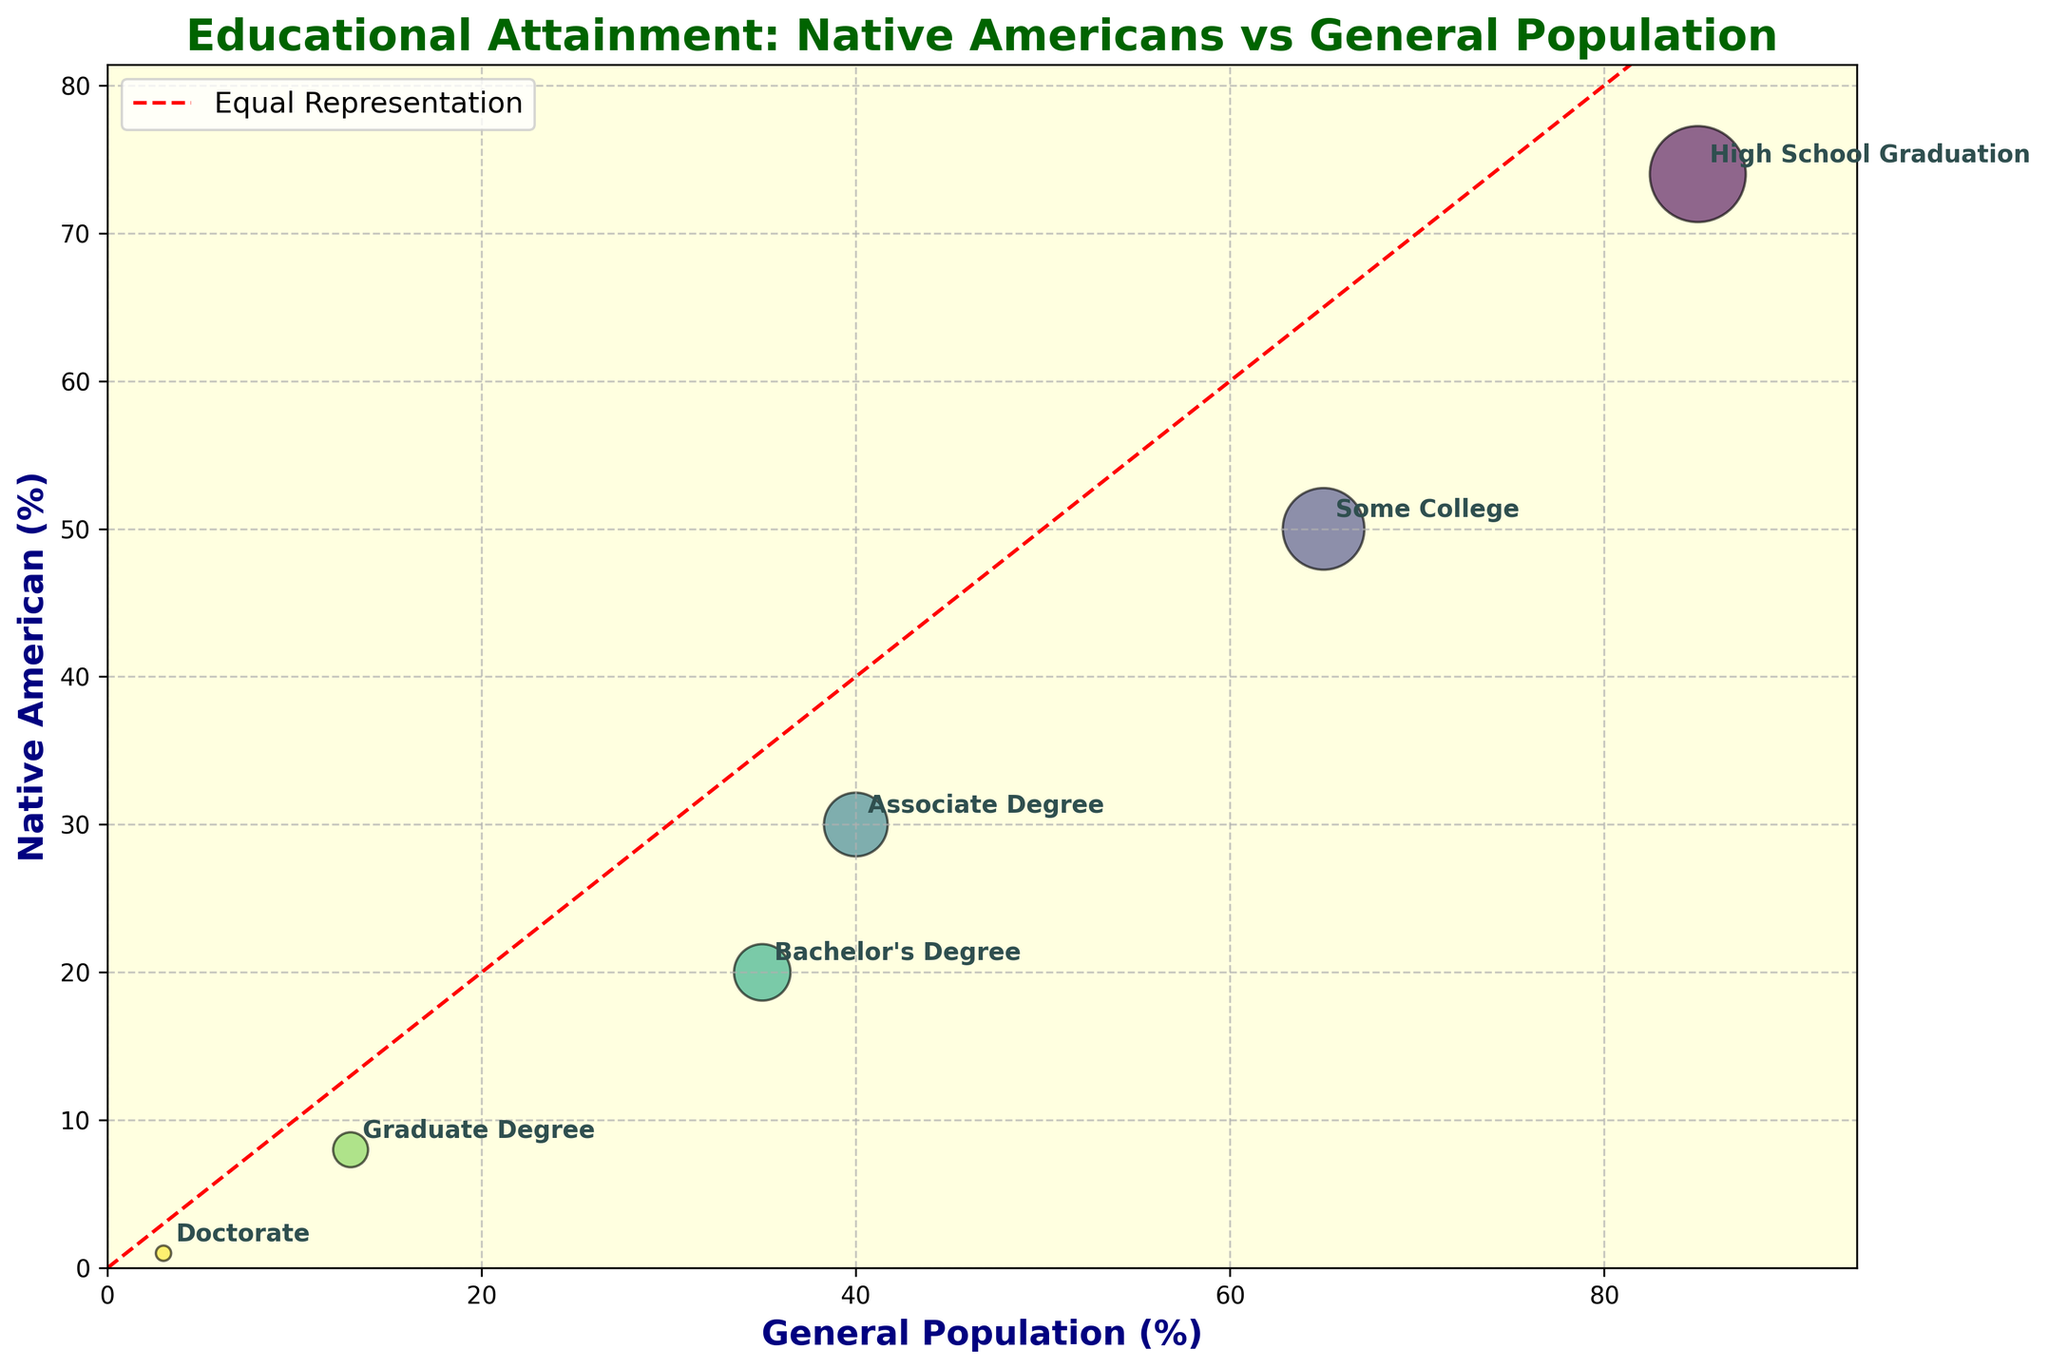What is the title of the figure? The title is displayed at the top of the figure. To find it, you can look at the text labeled in a larger font that summarizes what the plot represents.
Answer: Educational Attainment: Native Americans vs General Population How many educational levels are represented in the figure? By counting the number of bubbles in the plot, you can determine the number of data points or educational levels being compared.
Answer: 6 Which educational level has the lowest representation for Native Americans? Identify the bubble with the smallest y-value (Native American %). The label for this data point provides the educational level.
Answer: Doctorate What color is used to indicate different data points in the figure? You can see that each bubble has a distinct color drawn from a colormap, which is likely a gradient of hues for clarity in different points.
Answer: Various (color gradient) Which educational level shows the highest percentage of high school graduates in the general population? Look for the bubble with the highest x-value (General Population %). The label attached to this point indicates the corresponding educational level.
Answer: High School Graduation Which educational level shows the greatest disparity between Native Americans and the general population? To find the greatest disparity, look for the largest vertical distance between the x=y line and a given bubble on the plot.
Answer: Doctorate By how much percentage are Native Americans underrepresented in obtaining a Bachelor's Degree compared to the general population? Compare the y-value (Native American %) and x-value (General Population %) for the Bachelor's Degree bubble, then calculate the difference (General Population % - Native American %).
Answer: 15% What's the average representation of both Native Americans and the General Population for a Graduate Degree? Add the Native American % and General Population % values for the Graduate Degree, then divide by 2 to find the average.
Answer: 10.5% What is the trend between Native American representation and the general population as the education level increases? By examining the plot, identify if the Native American % decreases steadily compared to the General Population % as you move from High School Graduation to Doctorate.
Answer: Underrepresentation increases Which data point lies closest to the equal representation line (x=y)? Calculate the distance of each bubble from the red dashed line representing equal representation. The closest bubble will have the education level label indicating which data point it is.
Answer: Graduate Degree 